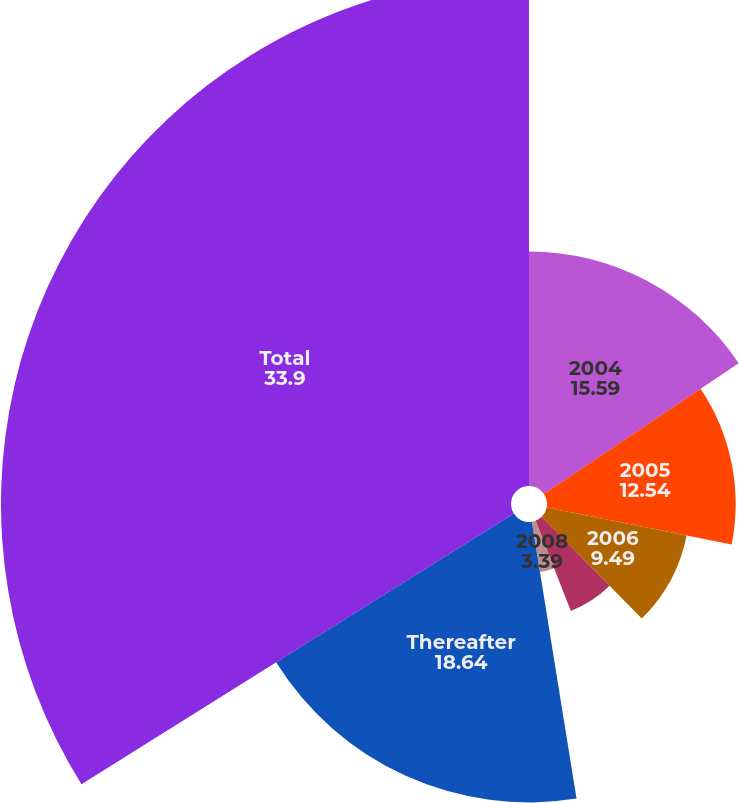Convert chart. <chart><loc_0><loc_0><loc_500><loc_500><pie_chart><fcel>2004<fcel>2005<fcel>2006<fcel>2007<fcel>2008<fcel>Thereafter<fcel>Total<nl><fcel>15.59%<fcel>12.54%<fcel>9.49%<fcel>6.44%<fcel>3.39%<fcel>18.64%<fcel>33.9%<nl></chart> 